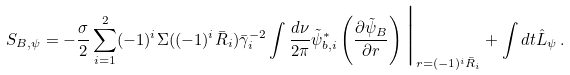<formula> <loc_0><loc_0><loc_500><loc_500>S _ { B , \psi } = - \frac { \sigma } { 2 } \sum _ { i = 1 } ^ { 2 } ( - 1 ) ^ { i } \Sigma ( ( - 1 ) ^ { i } \bar { R } _ { i } ) \bar { \gamma } _ { i } ^ { - 2 } \int \frac { d \nu } { 2 \pi } \tilde { \psi } _ { b , i } ^ { * } \left ( \frac { \partial \tilde { \psi } _ { B } } { \partial r } \right ) \Big | _ { r = ( - 1 ) ^ { i } \bar { R } _ { i } } + \int d t \hat { L } _ { \psi } \, .</formula> 